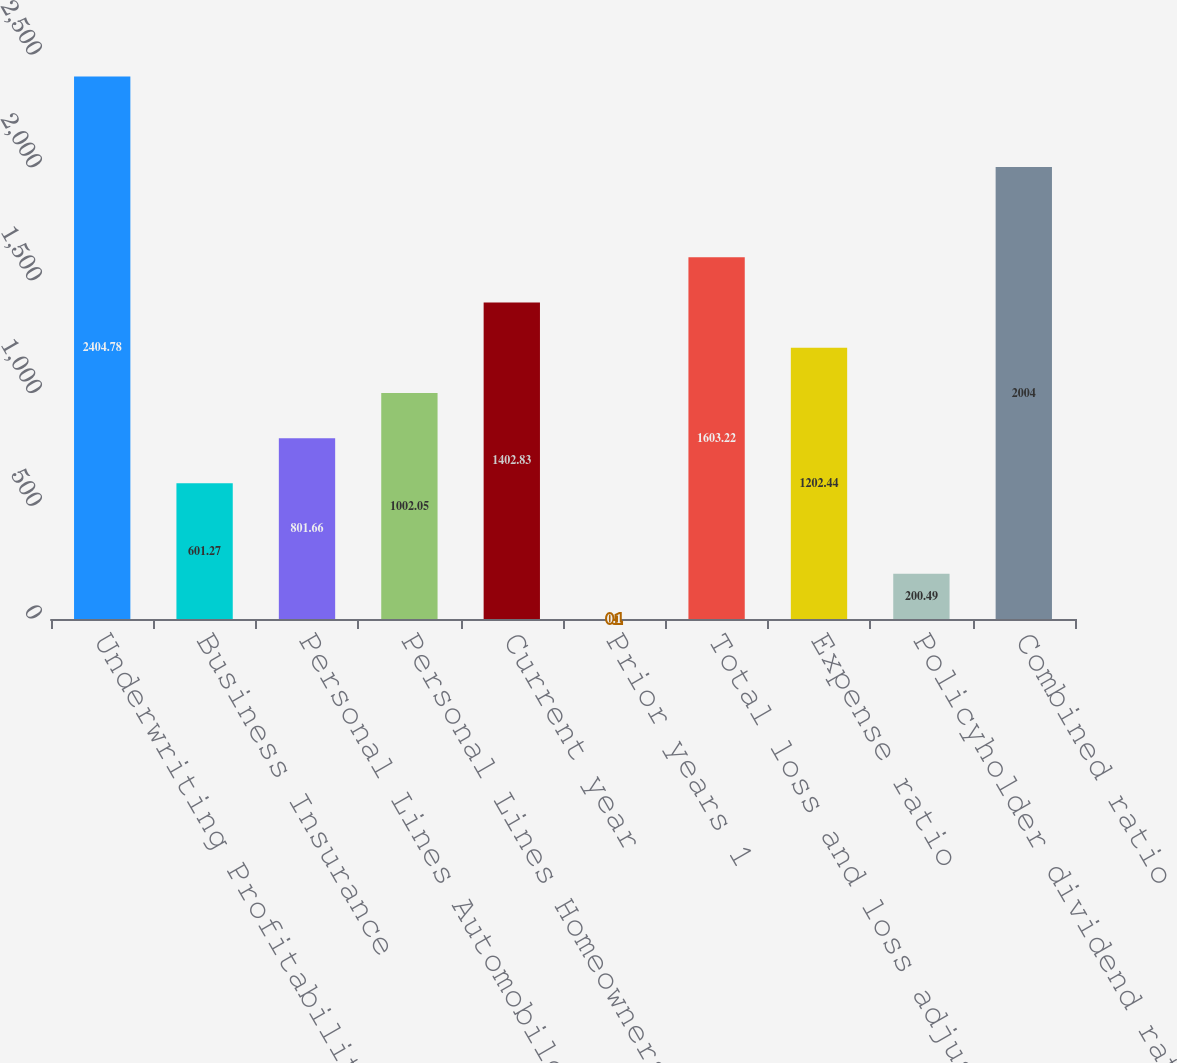Convert chart. <chart><loc_0><loc_0><loc_500><loc_500><bar_chart><fcel>Underwriting Profitability<fcel>Business Insurance<fcel>Personal Lines Automobile<fcel>Personal Lines Homeowners<fcel>Current year<fcel>Prior years 1<fcel>Total loss and loss adjustment<fcel>Expense ratio<fcel>Policyholder dividend ratio<fcel>Combined ratio<nl><fcel>2404.78<fcel>601.27<fcel>801.66<fcel>1002.05<fcel>1402.83<fcel>0.1<fcel>1603.22<fcel>1202.44<fcel>200.49<fcel>2004<nl></chart> 